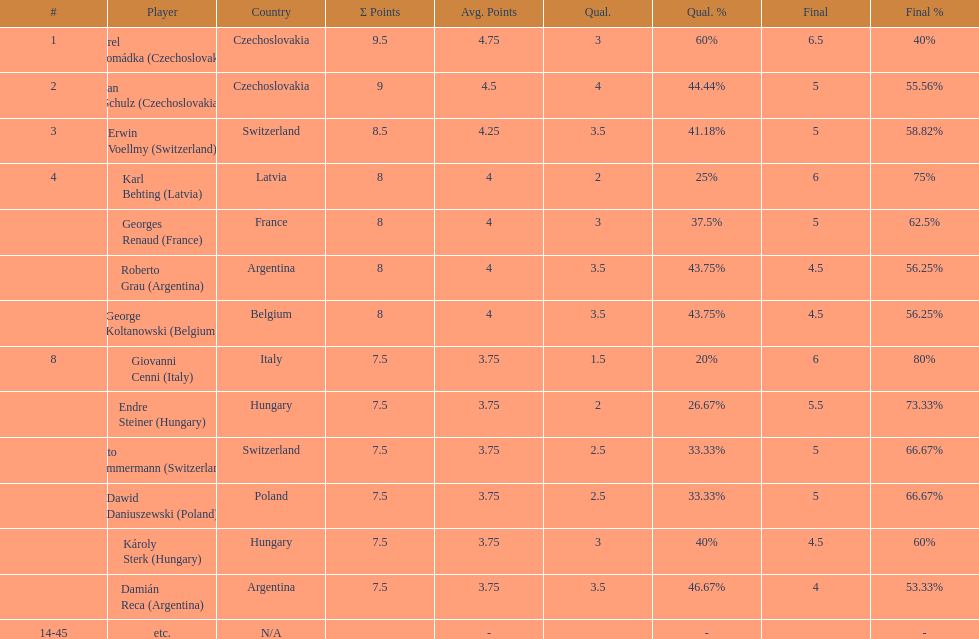Did the two competitors from hungary get more or less combined points than the two competitors from argentina? Less. 